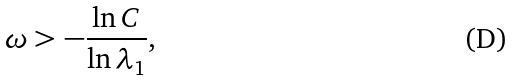<formula> <loc_0><loc_0><loc_500><loc_500>\omega > - \frac { \ln C } { \ln \lambda _ { 1 } } ,</formula> 